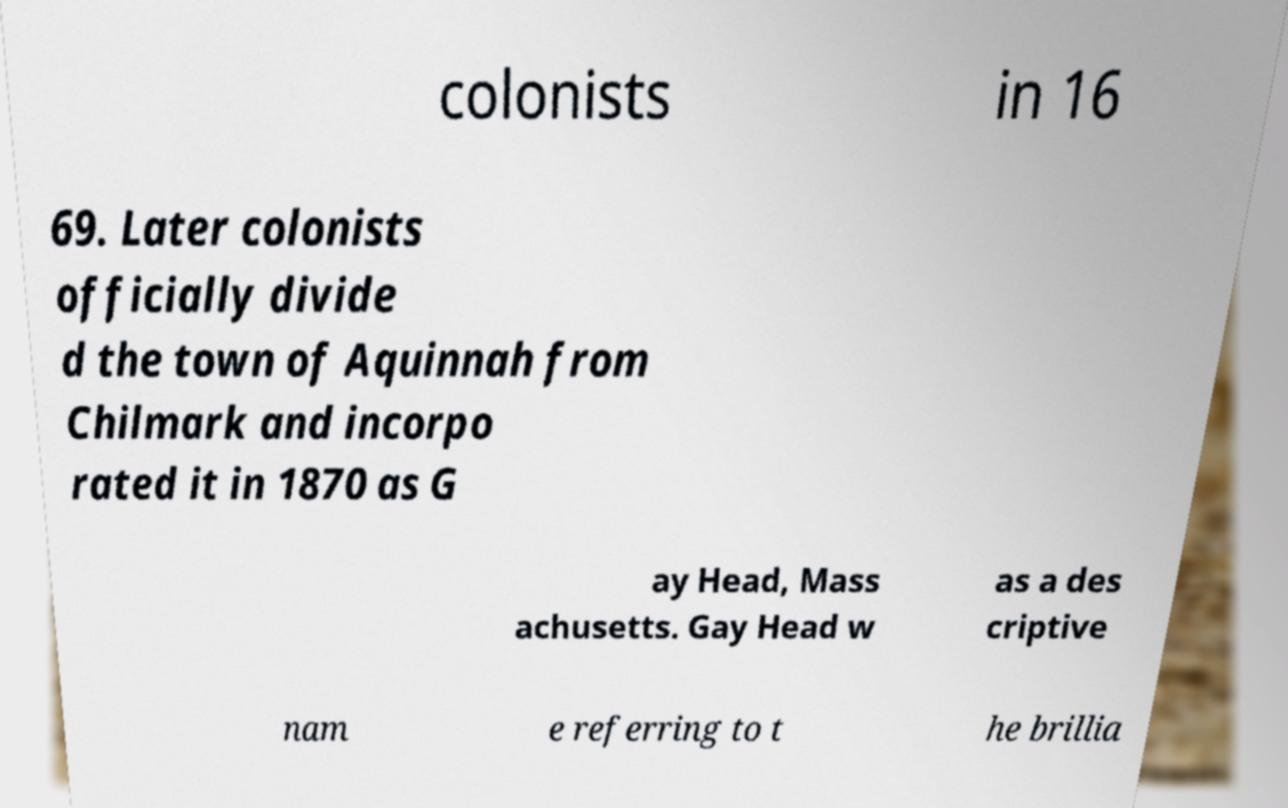Please identify and transcribe the text found in this image. colonists in 16 69. Later colonists officially divide d the town of Aquinnah from Chilmark and incorpo rated it in 1870 as G ay Head, Mass achusetts. Gay Head w as a des criptive nam e referring to t he brillia 